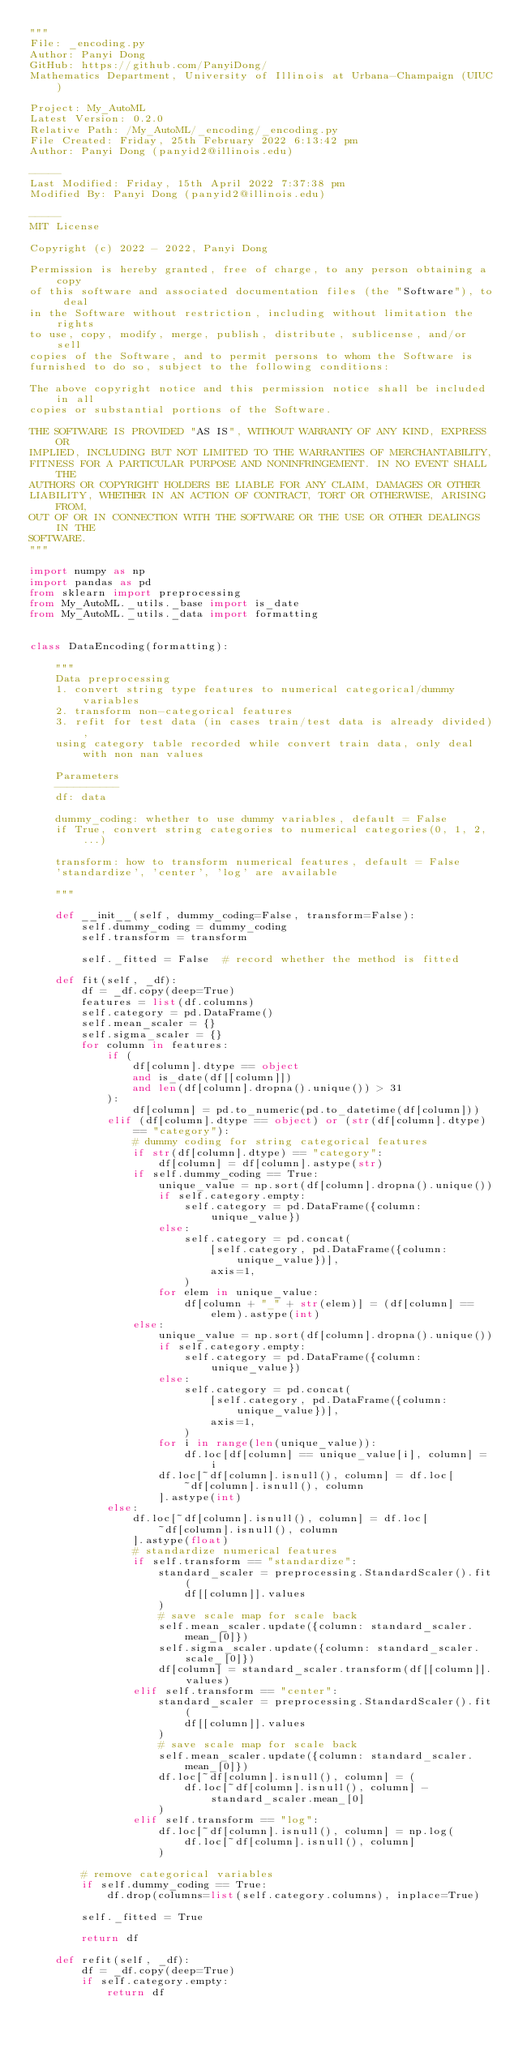Convert code to text. <code><loc_0><loc_0><loc_500><loc_500><_Python_>"""
File: _encoding.py
Author: Panyi Dong
GitHub: https://github.com/PanyiDong/
Mathematics Department, University of Illinois at Urbana-Champaign (UIUC)

Project: My_AutoML
Latest Version: 0.2.0
Relative Path: /My_AutoML/_encoding/_encoding.py
File Created: Friday, 25th February 2022 6:13:42 pm
Author: Panyi Dong (panyid2@illinois.edu)

-----
Last Modified: Friday, 15th April 2022 7:37:38 pm
Modified By: Panyi Dong (panyid2@illinois.edu)

-----
MIT License

Copyright (c) 2022 - 2022, Panyi Dong

Permission is hereby granted, free of charge, to any person obtaining a copy
of this software and associated documentation files (the "Software"), to deal
in the Software without restriction, including without limitation the rights
to use, copy, modify, merge, publish, distribute, sublicense, and/or sell
copies of the Software, and to permit persons to whom the Software is
furnished to do so, subject to the following conditions:

The above copyright notice and this permission notice shall be included in all
copies or substantial portions of the Software.

THE SOFTWARE IS PROVIDED "AS IS", WITHOUT WARRANTY OF ANY KIND, EXPRESS OR
IMPLIED, INCLUDING BUT NOT LIMITED TO THE WARRANTIES OF MERCHANTABILITY,
FITNESS FOR A PARTICULAR PURPOSE AND NONINFRINGEMENT. IN NO EVENT SHALL THE
AUTHORS OR COPYRIGHT HOLDERS BE LIABLE FOR ANY CLAIM, DAMAGES OR OTHER
LIABILITY, WHETHER IN AN ACTION OF CONTRACT, TORT OR OTHERWISE, ARISING FROM,
OUT OF OR IN CONNECTION WITH THE SOFTWARE OR THE USE OR OTHER DEALINGS IN THE
SOFTWARE.
"""

import numpy as np
import pandas as pd
from sklearn import preprocessing
from My_AutoML._utils._base import is_date
from My_AutoML._utils._data import formatting


class DataEncoding(formatting):

    """
    Data preprocessing
    1. convert string type features to numerical categorical/dummy variables
    2. transform non-categorical features
    3. refit for test data (in cases train/test data is already divided),
    using category table recorded while convert train data, only deal with non nan values

    Parameters
    ----------
    df: data

    dummy_coding: whether to use dummy variables, default = False
    if True, convert string categories to numerical categories(0, 1, 2, ...)

    transform: how to transform numerical features, default = False
    'standardize', 'center', 'log' are available

    """

    def __init__(self, dummy_coding=False, transform=False):
        self.dummy_coding = dummy_coding
        self.transform = transform

        self._fitted = False  # record whether the method is fitted

    def fit(self, _df):
        df = _df.copy(deep=True)
        features = list(df.columns)
        self.category = pd.DataFrame()
        self.mean_scaler = {}
        self.sigma_scaler = {}
        for column in features:
            if (
                df[column].dtype == object
                and is_date(df[[column]])
                and len(df[column].dropna().unique()) > 31
            ):
                df[column] = pd.to_numeric(pd.to_datetime(df[column]))
            elif (df[column].dtype == object) or (str(df[column].dtype) == "category"):
                # dummy coding for string categorical features
                if str(df[column].dtype) == "category":
                    df[column] = df[column].astype(str)
                if self.dummy_coding == True:
                    unique_value = np.sort(df[column].dropna().unique())
                    if self.category.empty:
                        self.category = pd.DataFrame({column: unique_value})
                    else:
                        self.category = pd.concat(
                            [self.category, pd.DataFrame({column: unique_value})],
                            axis=1,
                        )
                    for elem in unique_value:
                        df[column + "_" + str(elem)] = (df[column] == elem).astype(int)
                else:
                    unique_value = np.sort(df[column].dropna().unique())
                    if self.category.empty:
                        self.category = pd.DataFrame({column: unique_value})
                    else:
                        self.category = pd.concat(
                            [self.category, pd.DataFrame({column: unique_value})],
                            axis=1,
                        )
                    for i in range(len(unique_value)):
                        df.loc[df[column] == unique_value[i], column] = i
                    df.loc[~df[column].isnull(), column] = df.loc[
                        ~df[column].isnull(), column
                    ].astype(int)
            else:
                df.loc[~df[column].isnull(), column] = df.loc[
                    ~df[column].isnull(), column
                ].astype(float)
                # standardize numerical features
                if self.transform == "standardize":
                    standard_scaler = preprocessing.StandardScaler().fit(
                        df[[column]].values
                    )
                    # save scale map for scale back
                    self.mean_scaler.update({column: standard_scaler.mean_[0]})
                    self.sigma_scaler.update({column: standard_scaler.scale_[0]})
                    df[column] = standard_scaler.transform(df[[column]].values)
                elif self.transform == "center":
                    standard_scaler = preprocessing.StandardScaler().fit(
                        df[[column]].values
                    )
                    # save scale map for scale back
                    self.mean_scaler.update({column: standard_scaler.mean_[0]})
                    df.loc[~df[column].isnull(), column] = (
                        df.loc[~df[column].isnull(), column] - standard_scaler.mean_[0]
                    )
                elif self.transform == "log":
                    df.loc[~df[column].isnull(), column] = np.log(
                        df.loc[~df[column].isnull(), column]
                    )

        # remove categorical variables
        if self.dummy_coding == True:
            df.drop(columns=list(self.category.columns), inplace=True)

        self._fitted = True

        return df

    def refit(self, _df):
        df = _df.copy(deep=True)
        if self.category.empty:
            return df</code> 